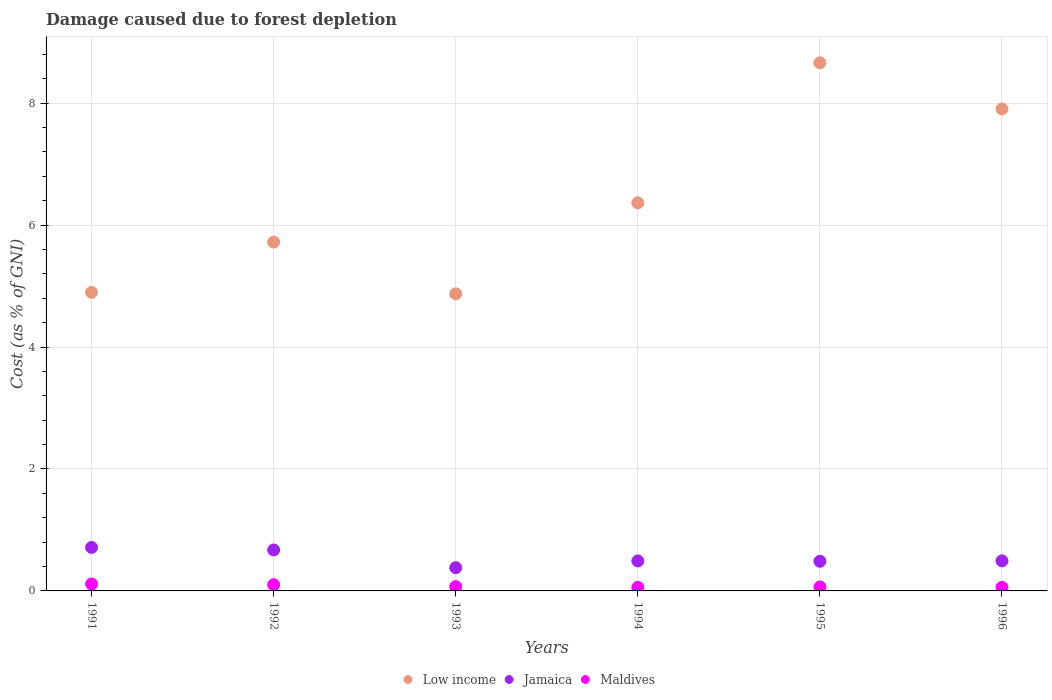How many different coloured dotlines are there?
Give a very brief answer. 3. What is the cost of damage caused due to forest depletion in Maldives in 1995?
Provide a short and direct response. 0.06. Across all years, what is the maximum cost of damage caused due to forest depletion in Maldives?
Your answer should be compact. 0.11. Across all years, what is the minimum cost of damage caused due to forest depletion in Jamaica?
Your answer should be compact. 0.38. In which year was the cost of damage caused due to forest depletion in Low income minimum?
Your response must be concise. 1993. What is the total cost of damage caused due to forest depletion in Jamaica in the graph?
Your answer should be very brief. 3.24. What is the difference between the cost of damage caused due to forest depletion in Jamaica in 1992 and that in 1993?
Ensure brevity in your answer.  0.29. What is the difference between the cost of damage caused due to forest depletion in Low income in 1995 and the cost of damage caused due to forest depletion in Maldives in 1996?
Make the answer very short. 8.6. What is the average cost of damage caused due to forest depletion in Maldives per year?
Keep it short and to the point. 0.08. In the year 1994, what is the difference between the cost of damage caused due to forest depletion in Jamaica and cost of damage caused due to forest depletion in Maldives?
Keep it short and to the point. 0.43. In how many years, is the cost of damage caused due to forest depletion in Low income greater than 4 %?
Make the answer very short. 6. What is the ratio of the cost of damage caused due to forest depletion in Low income in 1991 to that in 1995?
Give a very brief answer. 0.57. Is the difference between the cost of damage caused due to forest depletion in Jamaica in 1992 and 1993 greater than the difference between the cost of damage caused due to forest depletion in Maldives in 1992 and 1993?
Your response must be concise. Yes. What is the difference between the highest and the second highest cost of damage caused due to forest depletion in Jamaica?
Keep it short and to the point. 0.04. What is the difference between the highest and the lowest cost of damage caused due to forest depletion in Maldives?
Provide a succinct answer. 0.05. In how many years, is the cost of damage caused due to forest depletion in Low income greater than the average cost of damage caused due to forest depletion in Low income taken over all years?
Your answer should be very brief. 2. Is it the case that in every year, the sum of the cost of damage caused due to forest depletion in Maldives and cost of damage caused due to forest depletion in Jamaica  is greater than the cost of damage caused due to forest depletion in Low income?
Your answer should be compact. No. Does the cost of damage caused due to forest depletion in Low income monotonically increase over the years?
Provide a succinct answer. No. Is the cost of damage caused due to forest depletion in Jamaica strictly greater than the cost of damage caused due to forest depletion in Maldives over the years?
Keep it short and to the point. Yes. How many dotlines are there?
Provide a short and direct response. 3. Does the graph contain any zero values?
Provide a short and direct response. No. Where does the legend appear in the graph?
Offer a very short reply. Bottom center. What is the title of the graph?
Give a very brief answer. Damage caused due to forest depletion. What is the label or title of the Y-axis?
Your response must be concise. Cost (as % of GNI). What is the Cost (as % of GNI) of Low income in 1991?
Your response must be concise. 4.9. What is the Cost (as % of GNI) in Jamaica in 1991?
Ensure brevity in your answer.  0.71. What is the Cost (as % of GNI) of Maldives in 1991?
Provide a short and direct response. 0.11. What is the Cost (as % of GNI) in Low income in 1992?
Make the answer very short. 5.72. What is the Cost (as % of GNI) in Jamaica in 1992?
Make the answer very short. 0.67. What is the Cost (as % of GNI) of Maldives in 1992?
Offer a terse response. 0.1. What is the Cost (as % of GNI) of Low income in 1993?
Your response must be concise. 4.87. What is the Cost (as % of GNI) of Jamaica in 1993?
Offer a very short reply. 0.38. What is the Cost (as % of GNI) in Maldives in 1993?
Provide a succinct answer. 0.07. What is the Cost (as % of GNI) in Low income in 1994?
Your answer should be very brief. 6.36. What is the Cost (as % of GNI) of Jamaica in 1994?
Offer a terse response. 0.49. What is the Cost (as % of GNI) of Maldives in 1994?
Provide a succinct answer. 0.06. What is the Cost (as % of GNI) in Low income in 1995?
Provide a succinct answer. 8.66. What is the Cost (as % of GNI) in Jamaica in 1995?
Keep it short and to the point. 0.49. What is the Cost (as % of GNI) of Maldives in 1995?
Your answer should be compact. 0.06. What is the Cost (as % of GNI) of Low income in 1996?
Your answer should be very brief. 7.9. What is the Cost (as % of GNI) in Jamaica in 1996?
Your answer should be compact. 0.49. What is the Cost (as % of GNI) of Maldives in 1996?
Keep it short and to the point. 0.06. Across all years, what is the maximum Cost (as % of GNI) in Low income?
Keep it short and to the point. 8.66. Across all years, what is the maximum Cost (as % of GNI) of Jamaica?
Offer a very short reply. 0.71. Across all years, what is the maximum Cost (as % of GNI) of Maldives?
Provide a short and direct response. 0.11. Across all years, what is the minimum Cost (as % of GNI) in Low income?
Keep it short and to the point. 4.87. Across all years, what is the minimum Cost (as % of GNI) in Jamaica?
Keep it short and to the point. 0.38. Across all years, what is the minimum Cost (as % of GNI) of Maldives?
Provide a succinct answer. 0.06. What is the total Cost (as % of GNI) of Low income in the graph?
Offer a very short reply. 38.42. What is the total Cost (as % of GNI) in Jamaica in the graph?
Offer a terse response. 3.24. What is the total Cost (as % of GNI) of Maldives in the graph?
Your answer should be compact. 0.47. What is the difference between the Cost (as % of GNI) in Low income in 1991 and that in 1992?
Ensure brevity in your answer.  -0.82. What is the difference between the Cost (as % of GNI) in Jamaica in 1991 and that in 1992?
Your response must be concise. 0.04. What is the difference between the Cost (as % of GNI) in Maldives in 1991 and that in 1992?
Provide a short and direct response. 0.01. What is the difference between the Cost (as % of GNI) of Low income in 1991 and that in 1993?
Offer a terse response. 0.02. What is the difference between the Cost (as % of GNI) of Jamaica in 1991 and that in 1993?
Give a very brief answer. 0.33. What is the difference between the Cost (as % of GNI) of Maldives in 1991 and that in 1993?
Provide a succinct answer. 0.04. What is the difference between the Cost (as % of GNI) of Low income in 1991 and that in 1994?
Your response must be concise. -1.47. What is the difference between the Cost (as % of GNI) of Jamaica in 1991 and that in 1994?
Give a very brief answer. 0.22. What is the difference between the Cost (as % of GNI) of Maldives in 1991 and that in 1994?
Your answer should be compact. 0.05. What is the difference between the Cost (as % of GNI) in Low income in 1991 and that in 1995?
Offer a very short reply. -3.76. What is the difference between the Cost (as % of GNI) of Jamaica in 1991 and that in 1995?
Provide a succinct answer. 0.23. What is the difference between the Cost (as % of GNI) in Maldives in 1991 and that in 1995?
Your response must be concise. 0.05. What is the difference between the Cost (as % of GNI) in Low income in 1991 and that in 1996?
Give a very brief answer. -3.01. What is the difference between the Cost (as % of GNI) of Jamaica in 1991 and that in 1996?
Ensure brevity in your answer.  0.22. What is the difference between the Cost (as % of GNI) in Maldives in 1991 and that in 1996?
Your response must be concise. 0.05. What is the difference between the Cost (as % of GNI) of Low income in 1992 and that in 1993?
Your answer should be very brief. 0.85. What is the difference between the Cost (as % of GNI) in Jamaica in 1992 and that in 1993?
Ensure brevity in your answer.  0.29. What is the difference between the Cost (as % of GNI) in Maldives in 1992 and that in 1993?
Your response must be concise. 0.03. What is the difference between the Cost (as % of GNI) in Low income in 1992 and that in 1994?
Your answer should be compact. -0.64. What is the difference between the Cost (as % of GNI) in Jamaica in 1992 and that in 1994?
Ensure brevity in your answer.  0.18. What is the difference between the Cost (as % of GNI) in Maldives in 1992 and that in 1994?
Your answer should be compact. 0.04. What is the difference between the Cost (as % of GNI) of Low income in 1992 and that in 1995?
Offer a very short reply. -2.94. What is the difference between the Cost (as % of GNI) in Jamaica in 1992 and that in 1995?
Provide a succinct answer. 0.19. What is the difference between the Cost (as % of GNI) of Maldives in 1992 and that in 1995?
Provide a succinct answer. 0.04. What is the difference between the Cost (as % of GNI) of Low income in 1992 and that in 1996?
Your answer should be very brief. -2.18. What is the difference between the Cost (as % of GNI) in Jamaica in 1992 and that in 1996?
Offer a very short reply. 0.18. What is the difference between the Cost (as % of GNI) of Maldives in 1992 and that in 1996?
Give a very brief answer. 0.04. What is the difference between the Cost (as % of GNI) of Low income in 1993 and that in 1994?
Provide a short and direct response. -1.49. What is the difference between the Cost (as % of GNI) in Jamaica in 1993 and that in 1994?
Offer a terse response. -0.11. What is the difference between the Cost (as % of GNI) in Maldives in 1993 and that in 1994?
Your response must be concise. 0.01. What is the difference between the Cost (as % of GNI) in Low income in 1993 and that in 1995?
Your answer should be very brief. -3.79. What is the difference between the Cost (as % of GNI) in Jamaica in 1993 and that in 1995?
Ensure brevity in your answer.  -0.1. What is the difference between the Cost (as % of GNI) of Maldives in 1993 and that in 1995?
Keep it short and to the point. 0.01. What is the difference between the Cost (as % of GNI) in Low income in 1993 and that in 1996?
Offer a terse response. -3.03. What is the difference between the Cost (as % of GNI) in Jamaica in 1993 and that in 1996?
Provide a succinct answer. -0.11. What is the difference between the Cost (as % of GNI) in Maldives in 1993 and that in 1996?
Keep it short and to the point. 0.01. What is the difference between the Cost (as % of GNI) in Low income in 1994 and that in 1995?
Provide a succinct answer. -2.3. What is the difference between the Cost (as % of GNI) of Jamaica in 1994 and that in 1995?
Make the answer very short. 0.01. What is the difference between the Cost (as % of GNI) of Maldives in 1994 and that in 1995?
Offer a very short reply. -0.01. What is the difference between the Cost (as % of GNI) of Low income in 1994 and that in 1996?
Provide a short and direct response. -1.54. What is the difference between the Cost (as % of GNI) of Jamaica in 1994 and that in 1996?
Your answer should be very brief. -0. What is the difference between the Cost (as % of GNI) of Maldives in 1994 and that in 1996?
Your response must be concise. 0. What is the difference between the Cost (as % of GNI) in Low income in 1995 and that in 1996?
Keep it short and to the point. 0.76. What is the difference between the Cost (as % of GNI) in Jamaica in 1995 and that in 1996?
Your answer should be very brief. -0.01. What is the difference between the Cost (as % of GNI) in Maldives in 1995 and that in 1996?
Your answer should be very brief. 0.01. What is the difference between the Cost (as % of GNI) in Low income in 1991 and the Cost (as % of GNI) in Jamaica in 1992?
Your answer should be compact. 4.22. What is the difference between the Cost (as % of GNI) of Low income in 1991 and the Cost (as % of GNI) of Maldives in 1992?
Keep it short and to the point. 4.79. What is the difference between the Cost (as % of GNI) of Jamaica in 1991 and the Cost (as % of GNI) of Maldives in 1992?
Offer a terse response. 0.61. What is the difference between the Cost (as % of GNI) of Low income in 1991 and the Cost (as % of GNI) of Jamaica in 1993?
Provide a short and direct response. 4.52. What is the difference between the Cost (as % of GNI) in Low income in 1991 and the Cost (as % of GNI) in Maldives in 1993?
Provide a succinct answer. 4.83. What is the difference between the Cost (as % of GNI) of Jamaica in 1991 and the Cost (as % of GNI) of Maldives in 1993?
Your response must be concise. 0.64. What is the difference between the Cost (as % of GNI) in Low income in 1991 and the Cost (as % of GNI) in Jamaica in 1994?
Provide a short and direct response. 4.41. What is the difference between the Cost (as % of GNI) of Low income in 1991 and the Cost (as % of GNI) of Maldives in 1994?
Your answer should be compact. 4.84. What is the difference between the Cost (as % of GNI) of Jamaica in 1991 and the Cost (as % of GNI) of Maldives in 1994?
Keep it short and to the point. 0.65. What is the difference between the Cost (as % of GNI) of Low income in 1991 and the Cost (as % of GNI) of Jamaica in 1995?
Your answer should be very brief. 4.41. What is the difference between the Cost (as % of GNI) of Low income in 1991 and the Cost (as % of GNI) of Maldives in 1995?
Make the answer very short. 4.83. What is the difference between the Cost (as % of GNI) in Jamaica in 1991 and the Cost (as % of GNI) in Maldives in 1995?
Offer a very short reply. 0.65. What is the difference between the Cost (as % of GNI) in Low income in 1991 and the Cost (as % of GNI) in Jamaica in 1996?
Offer a very short reply. 4.4. What is the difference between the Cost (as % of GNI) in Low income in 1991 and the Cost (as % of GNI) in Maldives in 1996?
Your answer should be very brief. 4.84. What is the difference between the Cost (as % of GNI) in Jamaica in 1991 and the Cost (as % of GNI) in Maldives in 1996?
Your response must be concise. 0.65. What is the difference between the Cost (as % of GNI) in Low income in 1992 and the Cost (as % of GNI) in Jamaica in 1993?
Your response must be concise. 5.34. What is the difference between the Cost (as % of GNI) in Low income in 1992 and the Cost (as % of GNI) in Maldives in 1993?
Ensure brevity in your answer.  5.65. What is the difference between the Cost (as % of GNI) of Jamaica in 1992 and the Cost (as % of GNI) of Maldives in 1993?
Offer a very short reply. 0.6. What is the difference between the Cost (as % of GNI) in Low income in 1992 and the Cost (as % of GNI) in Jamaica in 1994?
Your answer should be very brief. 5.23. What is the difference between the Cost (as % of GNI) of Low income in 1992 and the Cost (as % of GNI) of Maldives in 1994?
Keep it short and to the point. 5.66. What is the difference between the Cost (as % of GNI) in Jamaica in 1992 and the Cost (as % of GNI) in Maldives in 1994?
Make the answer very short. 0.61. What is the difference between the Cost (as % of GNI) of Low income in 1992 and the Cost (as % of GNI) of Jamaica in 1995?
Provide a succinct answer. 5.23. What is the difference between the Cost (as % of GNI) in Low income in 1992 and the Cost (as % of GNI) in Maldives in 1995?
Give a very brief answer. 5.66. What is the difference between the Cost (as % of GNI) of Jamaica in 1992 and the Cost (as % of GNI) of Maldives in 1995?
Your answer should be very brief. 0.61. What is the difference between the Cost (as % of GNI) in Low income in 1992 and the Cost (as % of GNI) in Jamaica in 1996?
Offer a very short reply. 5.23. What is the difference between the Cost (as % of GNI) in Low income in 1992 and the Cost (as % of GNI) in Maldives in 1996?
Your response must be concise. 5.66. What is the difference between the Cost (as % of GNI) of Jamaica in 1992 and the Cost (as % of GNI) of Maldives in 1996?
Provide a short and direct response. 0.61. What is the difference between the Cost (as % of GNI) in Low income in 1993 and the Cost (as % of GNI) in Jamaica in 1994?
Your response must be concise. 4.38. What is the difference between the Cost (as % of GNI) in Low income in 1993 and the Cost (as % of GNI) in Maldives in 1994?
Your answer should be very brief. 4.81. What is the difference between the Cost (as % of GNI) in Jamaica in 1993 and the Cost (as % of GNI) in Maldives in 1994?
Provide a succinct answer. 0.32. What is the difference between the Cost (as % of GNI) of Low income in 1993 and the Cost (as % of GNI) of Jamaica in 1995?
Ensure brevity in your answer.  4.39. What is the difference between the Cost (as % of GNI) of Low income in 1993 and the Cost (as % of GNI) of Maldives in 1995?
Your response must be concise. 4.81. What is the difference between the Cost (as % of GNI) in Jamaica in 1993 and the Cost (as % of GNI) in Maldives in 1995?
Your answer should be compact. 0.32. What is the difference between the Cost (as % of GNI) of Low income in 1993 and the Cost (as % of GNI) of Jamaica in 1996?
Keep it short and to the point. 4.38. What is the difference between the Cost (as % of GNI) in Low income in 1993 and the Cost (as % of GNI) in Maldives in 1996?
Provide a short and direct response. 4.81. What is the difference between the Cost (as % of GNI) of Jamaica in 1993 and the Cost (as % of GNI) of Maldives in 1996?
Provide a short and direct response. 0.32. What is the difference between the Cost (as % of GNI) in Low income in 1994 and the Cost (as % of GNI) in Jamaica in 1995?
Offer a very short reply. 5.88. What is the difference between the Cost (as % of GNI) of Low income in 1994 and the Cost (as % of GNI) of Maldives in 1995?
Offer a very short reply. 6.3. What is the difference between the Cost (as % of GNI) of Jamaica in 1994 and the Cost (as % of GNI) of Maldives in 1995?
Provide a succinct answer. 0.43. What is the difference between the Cost (as % of GNI) of Low income in 1994 and the Cost (as % of GNI) of Jamaica in 1996?
Your answer should be compact. 5.87. What is the difference between the Cost (as % of GNI) in Low income in 1994 and the Cost (as % of GNI) in Maldives in 1996?
Provide a short and direct response. 6.31. What is the difference between the Cost (as % of GNI) in Jamaica in 1994 and the Cost (as % of GNI) in Maldives in 1996?
Provide a short and direct response. 0.43. What is the difference between the Cost (as % of GNI) in Low income in 1995 and the Cost (as % of GNI) in Jamaica in 1996?
Ensure brevity in your answer.  8.17. What is the difference between the Cost (as % of GNI) of Low income in 1995 and the Cost (as % of GNI) of Maldives in 1996?
Your answer should be compact. 8.6. What is the difference between the Cost (as % of GNI) of Jamaica in 1995 and the Cost (as % of GNI) of Maldives in 1996?
Your answer should be very brief. 0.43. What is the average Cost (as % of GNI) in Low income per year?
Your response must be concise. 6.4. What is the average Cost (as % of GNI) in Jamaica per year?
Provide a succinct answer. 0.54. What is the average Cost (as % of GNI) of Maldives per year?
Make the answer very short. 0.08. In the year 1991, what is the difference between the Cost (as % of GNI) of Low income and Cost (as % of GNI) of Jamaica?
Offer a terse response. 4.18. In the year 1991, what is the difference between the Cost (as % of GNI) of Low income and Cost (as % of GNI) of Maldives?
Offer a very short reply. 4.78. In the year 1991, what is the difference between the Cost (as % of GNI) in Jamaica and Cost (as % of GNI) in Maldives?
Your answer should be very brief. 0.6. In the year 1992, what is the difference between the Cost (as % of GNI) in Low income and Cost (as % of GNI) in Jamaica?
Your answer should be compact. 5.05. In the year 1992, what is the difference between the Cost (as % of GNI) of Low income and Cost (as % of GNI) of Maldives?
Your response must be concise. 5.62. In the year 1992, what is the difference between the Cost (as % of GNI) in Jamaica and Cost (as % of GNI) in Maldives?
Your answer should be compact. 0.57. In the year 1993, what is the difference between the Cost (as % of GNI) in Low income and Cost (as % of GNI) in Jamaica?
Your response must be concise. 4.49. In the year 1993, what is the difference between the Cost (as % of GNI) in Low income and Cost (as % of GNI) in Maldives?
Give a very brief answer. 4.8. In the year 1993, what is the difference between the Cost (as % of GNI) in Jamaica and Cost (as % of GNI) in Maldives?
Your answer should be very brief. 0.31. In the year 1994, what is the difference between the Cost (as % of GNI) of Low income and Cost (as % of GNI) of Jamaica?
Ensure brevity in your answer.  5.87. In the year 1994, what is the difference between the Cost (as % of GNI) in Low income and Cost (as % of GNI) in Maldives?
Keep it short and to the point. 6.31. In the year 1994, what is the difference between the Cost (as % of GNI) in Jamaica and Cost (as % of GNI) in Maldives?
Your answer should be compact. 0.43. In the year 1995, what is the difference between the Cost (as % of GNI) in Low income and Cost (as % of GNI) in Jamaica?
Give a very brief answer. 8.18. In the year 1995, what is the difference between the Cost (as % of GNI) of Low income and Cost (as % of GNI) of Maldives?
Make the answer very short. 8.6. In the year 1995, what is the difference between the Cost (as % of GNI) in Jamaica and Cost (as % of GNI) in Maldives?
Provide a short and direct response. 0.42. In the year 1996, what is the difference between the Cost (as % of GNI) of Low income and Cost (as % of GNI) of Jamaica?
Your answer should be compact. 7.41. In the year 1996, what is the difference between the Cost (as % of GNI) of Low income and Cost (as % of GNI) of Maldives?
Offer a terse response. 7.85. In the year 1996, what is the difference between the Cost (as % of GNI) in Jamaica and Cost (as % of GNI) in Maldives?
Keep it short and to the point. 0.43. What is the ratio of the Cost (as % of GNI) in Low income in 1991 to that in 1992?
Make the answer very short. 0.86. What is the ratio of the Cost (as % of GNI) of Jamaica in 1991 to that in 1992?
Offer a terse response. 1.06. What is the ratio of the Cost (as % of GNI) in Maldives in 1991 to that in 1992?
Provide a succinct answer. 1.11. What is the ratio of the Cost (as % of GNI) in Jamaica in 1991 to that in 1993?
Keep it short and to the point. 1.87. What is the ratio of the Cost (as % of GNI) of Maldives in 1991 to that in 1993?
Your answer should be very brief. 1.59. What is the ratio of the Cost (as % of GNI) of Low income in 1991 to that in 1994?
Your response must be concise. 0.77. What is the ratio of the Cost (as % of GNI) of Jamaica in 1991 to that in 1994?
Ensure brevity in your answer.  1.45. What is the ratio of the Cost (as % of GNI) in Maldives in 1991 to that in 1994?
Your answer should be compact. 1.93. What is the ratio of the Cost (as % of GNI) of Low income in 1991 to that in 1995?
Offer a very short reply. 0.57. What is the ratio of the Cost (as % of GNI) in Jamaica in 1991 to that in 1995?
Provide a succinct answer. 1.47. What is the ratio of the Cost (as % of GNI) of Maldives in 1991 to that in 1995?
Make the answer very short. 1.75. What is the ratio of the Cost (as % of GNI) of Low income in 1991 to that in 1996?
Your answer should be very brief. 0.62. What is the ratio of the Cost (as % of GNI) of Jamaica in 1991 to that in 1996?
Your answer should be compact. 1.45. What is the ratio of the Cost (as % of GNI) in Maldives in 1991 to that in 1996?
Your answer should be very brief. 1.93. What is the ratio of the Cost (as % of GNI) in Low income in 1992 to that in 1993?
Your answer should be compact. 1.17. What is the ratio of the Cost (as % of GNI) of Jamaica in 1992 to that in 1993?
Ensure brevity in your answer.  1.76. What is the ratio of the Cost (as % of GNI) in Maldives in 1992 to that in 1993?
Ensure brevity in your answer.  1.43. What is the ratio of the Cost (as % of GNI) of Low income in 1992 to that in 1994?
Your answer should be very brief. 0.9. What is the ratio of the Cost (as % of GNI) in Jamaica in 1992 to that in 1994?
Make the answer very short. 1.37. What is the ratio of the Cost (as % of GNI) of Maldives in 1992 to that in 1994?
Make the answer very short. 1.73. What is the ratio of the Cost (as % of GNI) in Low income in 1992 to that in 1995?
Your answer should be very brief. 0.66. What is the ratio of the Cost (as % of GNI) in Jamaica in 1992 to that in 1995?
Ensure brevity in your answer.  1.38. What is the ratio of the Cost (as % of GNI) in Maldives in 1992 to that in 1995?
Make the answer very short. 1.58. What is the ratio of the Cost (as % of GNI) of Low income in 1992 to that in 1996?
Give a very brief answer. 0.72. What is the ratio of the Cost (as % of GNI) of Jamaica in 1992 to that in 1996?
Ensure brevity in your answer.  1.36. What is the ratio of the Cost (as % of GNI) of Maldives in 1992 to that in 1996?
Offer a terse response. 1.73. What is the ratio of the Cost (as % of GNI) in Low income in 1993 to that in 1994?
Give a very brief answer. 0.77. What is the ratio of the Cost (as % of GNI) of Jamaica in 1993 to that in 1994?
Offer a terse response. 0.77. What is the ratio of the Cost (as % of GNI) in Maldives in 1993 to that in 1994?
Provide a succinct answer. 1.21. What is the ratio of the Cost (as % of GNI) of Low income in 1993 to that in 1995?
Your answer should be very brief. 0.56. What is the ratio of the Cost (as % of GNI) in Jamaica in 1993 to that in 1995?
Offer a terse response. 0.78. What is the ratio of the Cost (as % of GNI) in Maldives in 1993 to that in 1995?
Your response must be concise. 1.1. What is the ratio of the Cost (as % of GNI) of Low income in 1993 to that in 1996?
Offer a terse response. 0.62. What is the ratio of the Cost (as % of GNI) in Jamaica in 1993 to that in 1996?
Keep it short and to the point. 0.77. What is the ratio of the Cost (as % of GNI) in Maldives in 1993 to that in 1996?
Ensure brevity in your answer.  1.21. What is the ratio of the Cost (as % of GNI) of Low income in 1994 to that in 1995?
Make the answer very short. 0.73. What is the ratio of the Cost (as % of GNI) in Jamaica in 1994 to that in 1995?
Make the answer very short. 1.01. What is the ratio of the Cost (as % of GNI) of Maldives in 1994 to that in 1995?
Provide a short and direct response. 0.91. What is the ratio of the Cost (as % of GNI) in Low income in 1994 to that in 1996?
Your answer should be very brief. 0.81. What is the ratio of the Cost (as % of GNI) of Jamaica in 1994 to that in 1996?
Ensure brevity in your answer.  1. What is the ratio of the Cost (as % of GNI) in Maldives in 1994 to that in 1996?
Your response must be concise. 1. What is the ratio of the Cost (as % of GNI) of Low income in 1995 to that in 1996?
Provide a short and direct response. 1.1. What is the ratio of the Cost (as % of GNI) of Jamaica in 1995 to that in 1996?
Provide a succinct answer. 0.98. What is the ratio of the Cost (as % of GNI) in Maldives in 1995 to that in 1996?
Offer a terse response. 1.1. What is the difference between the highest and the second highest Cost (as % of GNI) in Low income?
Your answer should be compact. 0.76. What is the difference between the highest and the second highest Cost (as % of GNI) in Jamaica?
Ensure brevity in your answer.  0.04. What is the difference between the highest and the second highest Cost (as % of GNI) in Maldives?
Make the answer very short. 0.01. What is the difference between the highest and the lowest Cost (as % of GNI) in Low income?
Your answer should be compact. 3.79. What is the difference between the highest and the lowest Cost (as % of GNI) of Jamaica?
Your answer should be compact. 0.33. What is the difference between the highest and the lowest Cost (as % of GNI) in Maldives?
Offer a terse response. 0.05. 